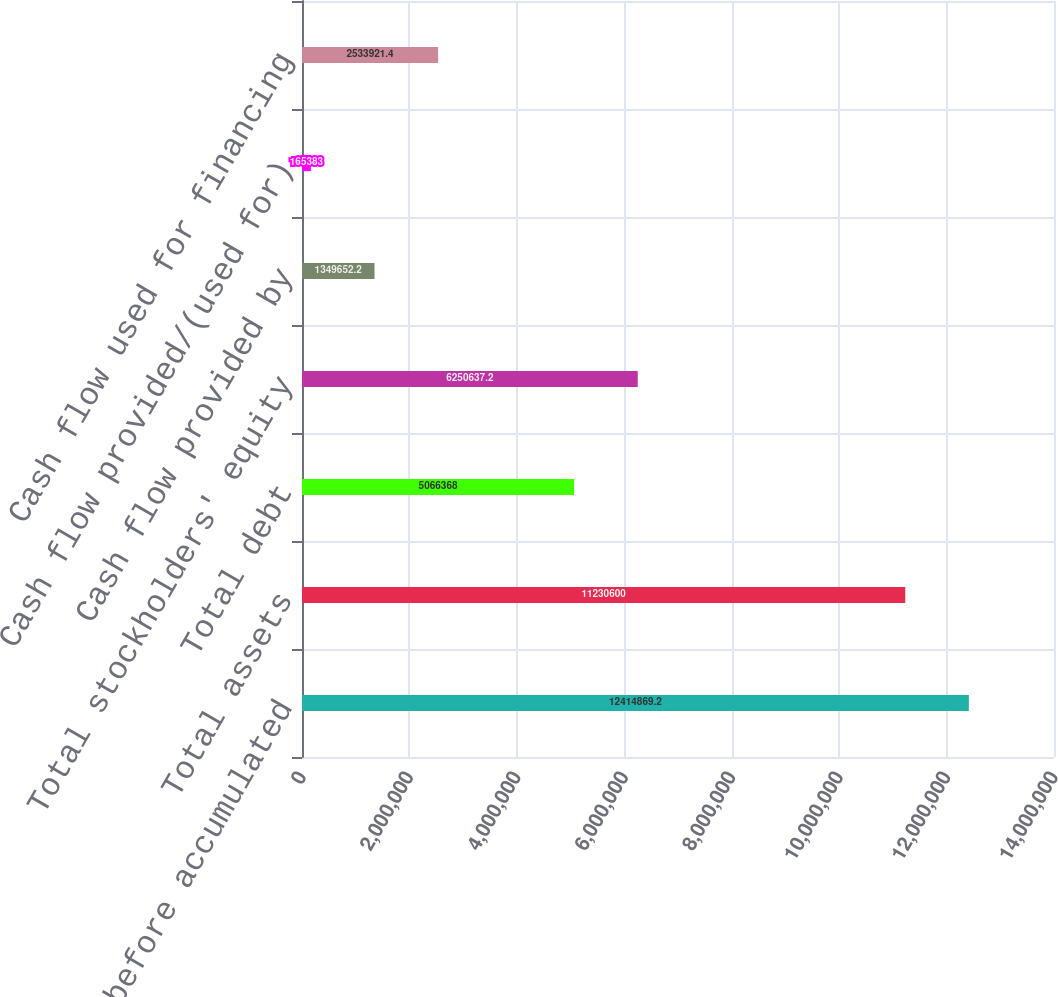Convert chart. <chart><loc_0><loc_0><loc_500><loc_500><bar_chart><fcel>Real estate before accumulated<fcel>Total assets<fcel>Total debt<fcel>Total stockholders' equity<fcel>Cash flow provided by<fcel>Cash flow provided/(used for)<fcel>Cash flow used for financing<nl><fcel>1.24149e+07<fcel>1.12306e+07<fcel>5.06637e+06<fcel>6.25064e+06<fcel>1.34965e+06<fcel>165383<fcel>2.53392e+06<nl></chart> 